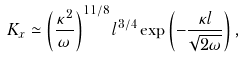Convert formula to latex. <formula><loc_0><loc_0><loc_500><loc_500>K _ { x } \simeq \left ( \frac { \kappa ^ { 2 } } { \omega } \right ) ^ { 1 1 / 8 } l ^ { 3 / 4 } \exp \left ( - \frac { \kappa l } { \sqrt { 2 \omega } } \right ) ,</formula> 